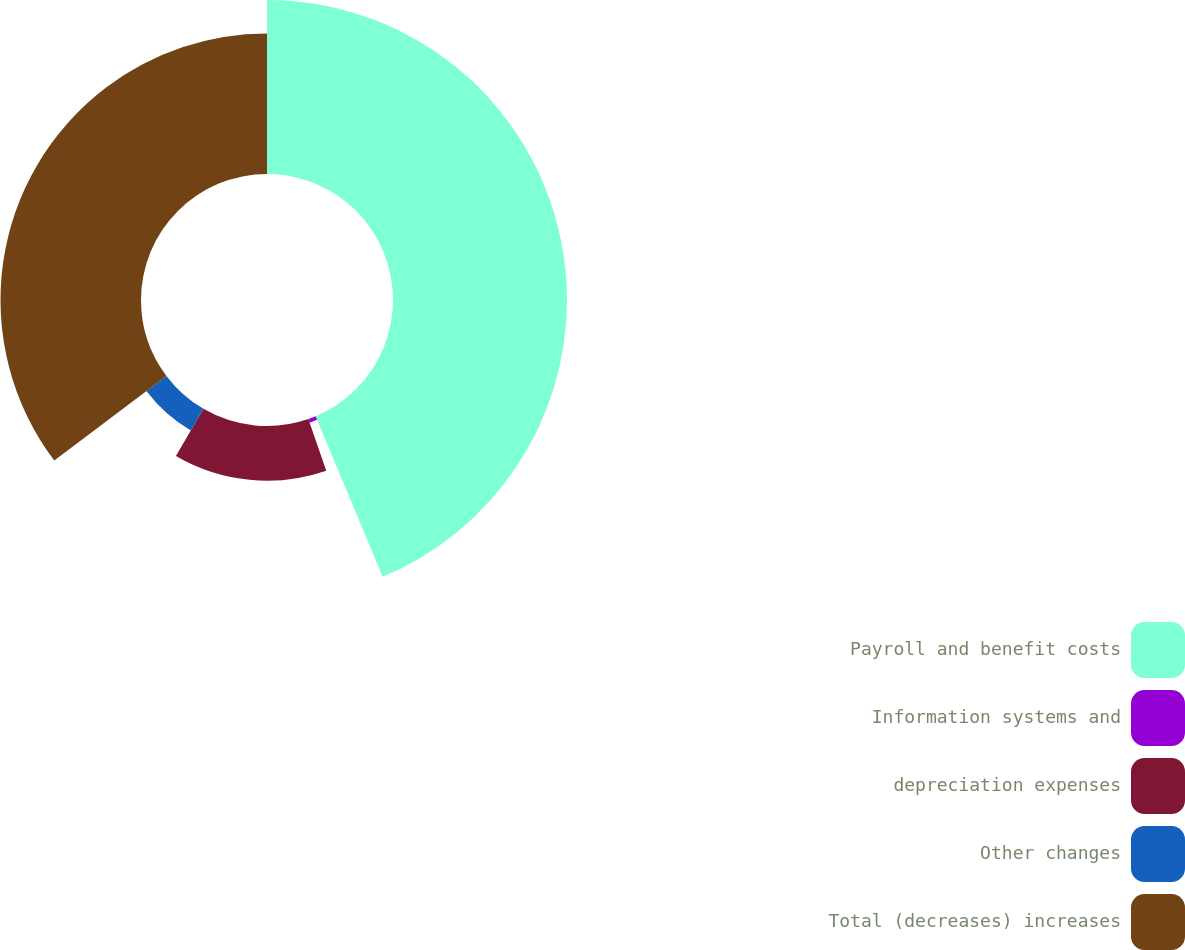Convert chart. <chart><loc_0><loc_0><loc_500><loc_500><pie_chart><fcel>Payroll and benefit costs<fcel>Information systems and<fcel>depreciation expenses<fcel>Other changes<fcel>Total (decreases) increases<nl><fcel>43.7%<fcel>0.98%<fcel>13.73%<fcel>6.3%<fcel>35.29%<nl></chart> 